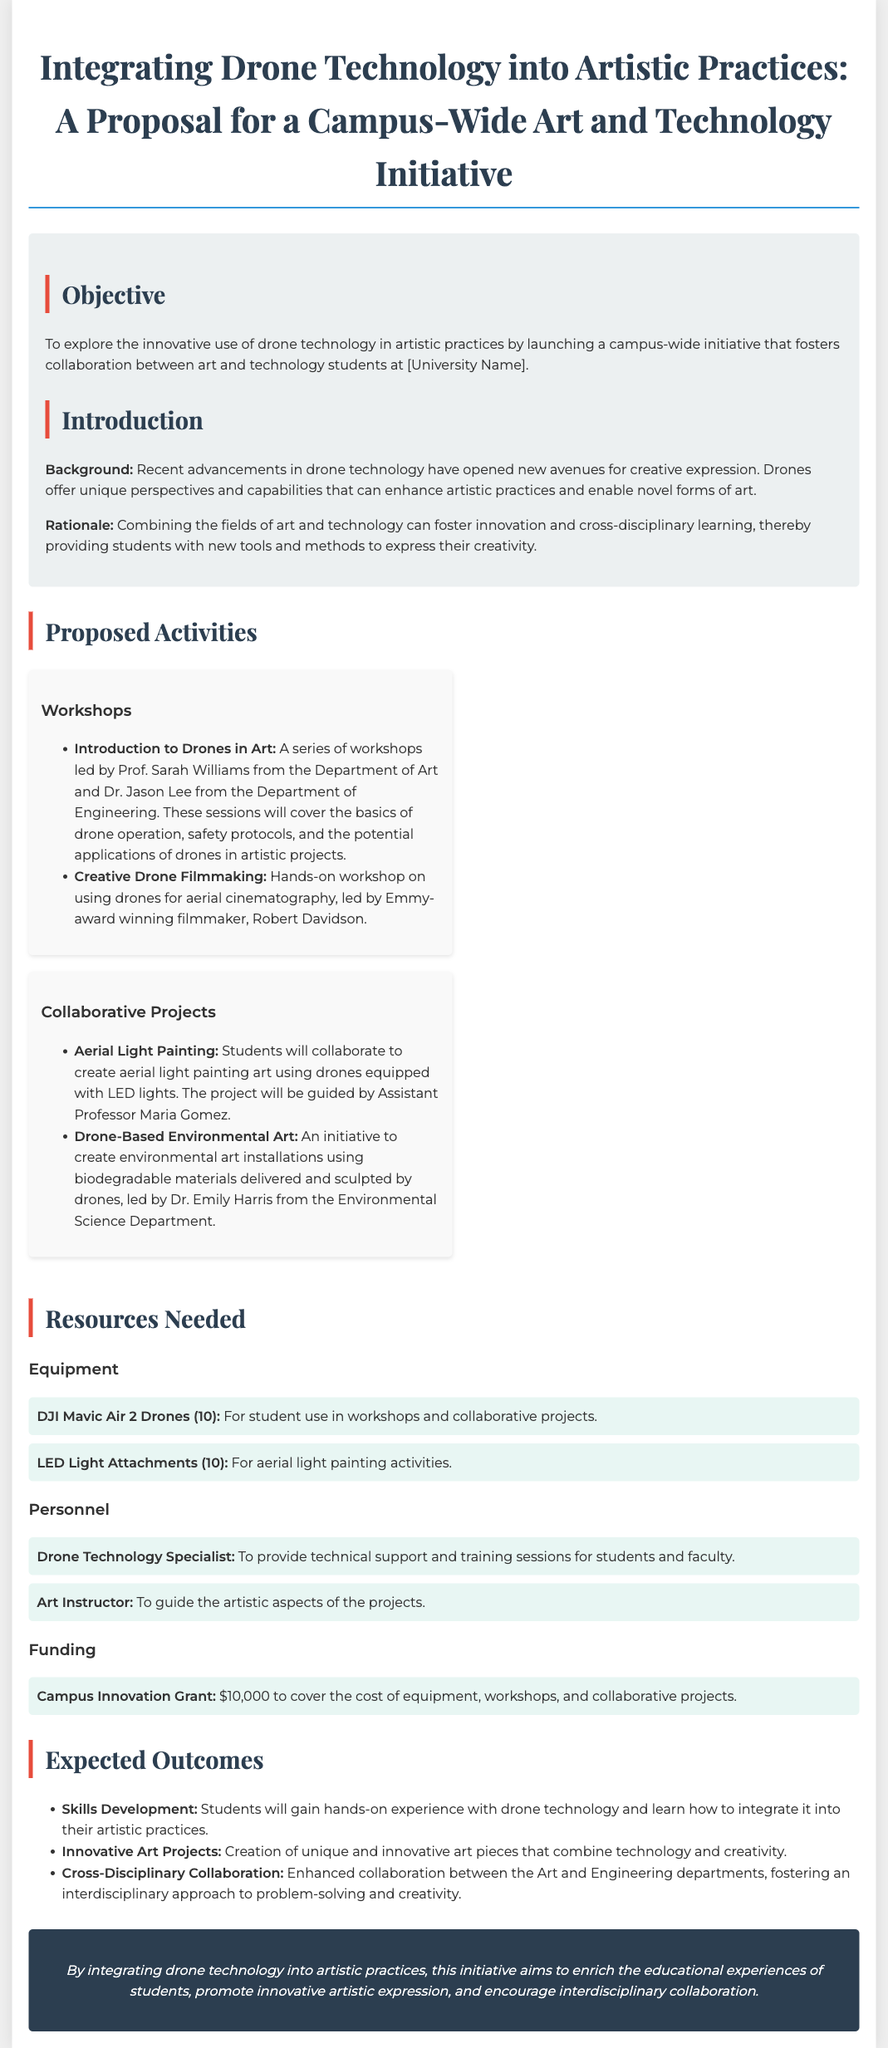What is the title of the proposal? The title of the proposal is stated prominently at the beginning of the document.
Answer: Integrating Drone Technology into Artistic Practices: A Proposal for a Campus-Wide Art and Technology Initiative Who is leading the workshop on creative drone filmmaking? The document mentions an Emmy-award winning filmmaker conducting this workshop.
Answer: Robert Davidson How many DJI Mavic Air 2 Drones are proposed? The number of drones required for student use in the document is specified clearly.
Answer: 10 What is the total funding amount requested for the initiative? The document specifies the amount of funding requested to cover various expenses related to the initiative.
Answer: $10,000 What type of art project is guided by Assistant Professor Maria Gomez? The document lists specific projects and their guides, including this collaborative project.
Answer: Aerial Light Painting What is one expected outcome of this initiative? The proposal describes several expected outcomes, one of which relates to students' skills development.
Answer: Skills Development Which departments are collaborating in this initiative? The document references two specific departments that will work together on this initiative.
Answer: Art and Engineering What is the objective of the proposal? The document states the primary aim at the beginning, providing clear insight into the proposal's goals.
Answer: To explore the innovative use of drone technology in artistic practices 